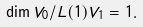<formula> <loc_0><loc_0><loc_500><loc_500>\dim V _ { 0 } / L ( 1 ) V _ { 1 } = 1 .</formula> 